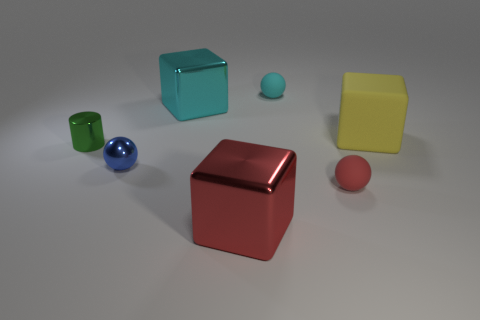Is the shape of the tiny rubber thing that is in front of the yellow thing the same as  the green metallic thing?
Give a very brief answer. No. Is there any other thing of the same color as the large matte cube?
Make the answer very short. No. There is a blue ball that is the same material as the big cyan object; what size is it?
Make the answer very short. Small. What is the large yellow block on the right side of the rubber ball right of the cyan object that is on the right side of the large red shiny block made of?
Provide a succinct answer. Rubber. Is the number of cyan rubber things less than the number of green balls?
Ensure brevity in your answer.  No. Is the big cyan object made of the same material as the big red thing?
Give a very brief answer. Yes. There is a small matte ball that is in front of the cyan sphere; does it have the same color as the large matte block?
Ensure brevity in your answer.  No. How many small green cylinders are on the right side of the small sphere behind the tiny blue object?
Provide a short and direct response. 0. What is the color of the metal thing that is the same size as the metallic sphere?
Ensure brevity in your answer.  Green. There is a large block that is in front of the small red matte thing; what is its material?
Your answer should be compact. Metal. 